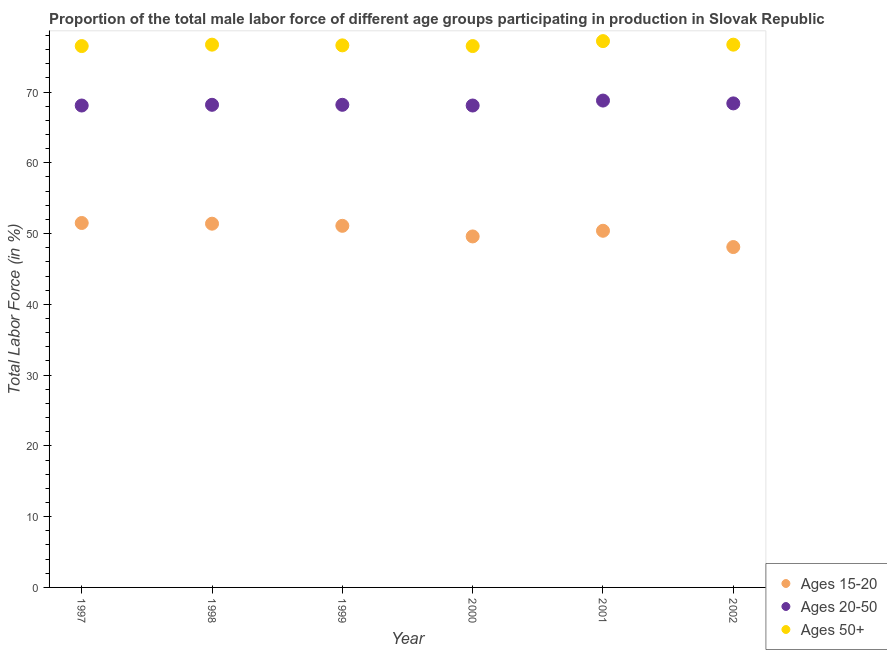How many different coloured dotlines are there?
Offer a very short reply. 3. Is the number of dotlines equal to the number of legend labels?
Keep it short and to the point. Yes. What is the percentage of male labor force within the age group 15-20 in 2002?
Your answer should be very brief. 48.1. Across all years, what is the maximum percentage of male labor force within the age group 15-20?
Your response must be concise. 51.5. Across all years, what is the minimum percentage of male labor force within the age group 20-50?
Offer a very short reply. 68.1. In which year was the percentage of male labor force above age 50 minimum?
Ensure brevity in your answer.  1997. What is the total percentage of male labor force within the age group 15-20 in the graph?
Keep it short and to the point. 302.1. What is the difference between the percentage of male labor force above age 50 in 1999 and that in 2002?
Provide a short and direct response. -0.1. What is the difference between the percentage of male labor force above age 50 in 1997 and the percentage of male labor force within the age group 20-50 in 2001?
Your answer should be compact. 7.7. What is the average percentage of male labor force above age 50 per year?
Make the answer very short. 76.7. In the year 2001, what is the difference between the percentage of male labor force within the age group 20-50 and percentage of male labor force above age 50?
Give a very brief answer. -8.4. In how many years, is the percentage of male labor force within the age group 15-20 greater than 22 %?
Make the answer very short. 6. What is the ratio of the percentage of male labor force within the age group 15-20 in 1997 to that in 1999?
Your answer should be very brief. 1.01. Is the difference between the percentage of male labor force within the age group 20-50 in 1997 and 2000 greater than the difference between the percentage of male labor force within the age group 15-20 in 1997 and 2000?
Provide a succinct answer. No. What is the difference between the highest and the second highest percentage of male labor force within the age group 15-20?
Offer a very short reply. 0.1. What is the difference between the highest and the lowest percentage of male labor force above age 50?
Provide a short and direct response. 0.7. Is it the case that in every year, the sum of the percentage of male labor force within the age group 15-20 and percentage of male labor force within the age group 20-50 is greater than the percentage of male labor force above age 50?
Ensure brevity in your answer.  Yes. How many years are there in the graph?
Give a very brief answer. 6. Does the graph contain any zero values?
Your answer should be very brief. No. Does the graph contain grids?
Make the answer very short. No. Where does the legend appear in the graph?
Provide a short and direct response. Bottom right. How many legend labels are there?
Offer a terse response. 3. How are the legend labels stacked?
Offer a terse response. Vertical. What is the title of the graph?
Your answer should be compact. Proportion of the total male labor force of different age groups participating in production in Slovak Republic. What is the label or title of the X-axis?
Your answer should be very brief. Year. What is the Total Labor Force (in %) of Ages 15-20 in 1997?
Provide a short and direct response. 51.5. What is the Total Labor Force (in %) in Ages 20-50 in 1997?
Your response must be concise. 68.1. What is the Total Labor Force (in %) in Ages 50+ in 1997?
Ensure brevity in your answer.  76.5. What is the Total Labor Force (in %) of Ages 15-20 in 1998?
Provide a succinct answer. 51.4. What is the Total Labor Force (in %) of Ages 20-50 in 1998?
Your answer should be very brief. 68.2. What is the Total Labor Force (in %) of Ages 50+ in 1998?
Provide a succinct answer. 76.7. What is the Total Labor Force (in %) in Ages 15-20 in 1999?
Provide a short and direct response. 51.1. What is the Total Labor Force (in %) of Ages 20-50 in 1999?
Your response must be concise. 68.2. What is the Total Labor Force (in %) of Ages 50+ in 1999?
Your response must be concise. 76.6. What is the Total Labor Force (in %) of Ages 15-20 in 2000?
Make the answer very short. 49.6. What is the Total Labor Force (in %) of Ages 20-50 in 2000?
Provide a short and direct response. 68.1. What is the Total Labor Force (in %) of Ages 50+ in 2000?
Ensure brevity in your answer.  76.5. What is the Total Labor Force (in %) of Ages 15-20 in 2001?
Give a very brief answer. 50.4. What is the Total Labor Force (in %) of Ages 20-50 in 2001?
Provide a succinct answer. 68.8. What is the Total Labor Force (in %) in Ages 50+ in 2001?
Give a very brief answer. 77.2. What is the Total Labor Force (in %) in Ages 15-20 in 2002?
Your response must be concise. 48.1. What is the Total Labor Force (in %) in Ages 20-50 in 2002?
Keep it short and to the point. 68.4. What is the Total Labor Force (in %) of Ages 50+ in 2002?
Keep it short and to the point. 76.7. Across all years, what is the maximum Total Labor Force (in %) in Ages 15-20?
Provide a short and direct response. 51.5. Across all years, what is the maximum Total Labor Force (in %) in Ages 20-50?
Your answer should be compact. 68.8. Across all years, what is the maximum Total Labor Force (in %) of Ages 50+?
Provide a short and direct response. 77.2. Across all years, what is the minimum Total Labor Force (in %) of Ages 15-20?
Give a very brief answer. 48.1. Across all years, what is the minimum Total Labor Force (in %) of Ages 20-50?
Give a very brief answer. 68.1. Across all years, what is the minimum Total Labor Force (in %) in Ages 50+?
Give a very brief answer. 76.5. What is the total Total Labor Force (in %) of Ages 15-20 in the graph?
Make the answer very short. 302.1. What is the total Total Labor Force (in %) of Ages 20-50 in the graph?
Offer a very short reply. 409.8. What is the total Total Labor Force (in %) in Ages 50+ in the graph?
Offer a very short reply. 460.2. What is the difference between the Total Labor Force (in %) in Ages 20-50 in 1997 and that in 2000?
Offer a terse response. 0. What is the difference between the Total Labor Force (in %) of Ages 50+ in 1997 and that in 2000?
Your answer should be very brief. 0. What is the difference between the Total Labor Force (in %) of Ages 20-50 in 1997 and that in 2001?
Your response must be concise. -0.7. What is the difference between the Total Labor Force (in %) of Ages 50+ in 1997 and that in 2002?
Your answer should be compact. -0.2. What is the difference between the Total Labor Force (in %) of Ages 20-50 in 1998 and that in 1999?
Provide a short and direct response. 0. What is the difference between the Total Labor Force (in %) in Ages 50+ in 1998 and that in 2001?
Offer a terse response. -0.5. What is the difference between the Total Labor Force (in %) of Ages 20-50 in 1999 and that in 2001?
Give a very brief answer. -0.6. What is the difference between the Total Labor Force (in %) in Ages 15-20 in 1999 and that in 2002?
Your answer should be very brief. 3. What is the difference between the Total Labor Force (in %) of Ages 50+ in 1999 and that in 2002?
Your answer should be compact. -0.1. What is the difference between the Total Labor Force (in %) of Ages 15-20 in 2000 and that in 2001?
Your response must be concise. -0.8. What is the difference between the Total Labor Force (in %) in Ages 20-50 in 2000 and that in 2001?
Your response must be concise. -0.7. What is the difference between the Total Labor Force (in %) in Ages 50+ in 2000 and that in 2001?
Make the answer very short. -0.7. What is the difference between the Total Labor Force (in %) of Ages 20-50 in 2000 and that in 2002?
Offer a very short reply. -0.3. What is the difference between the Total Labor Force (in %) in Ages 15-20 in 2001 and that in 2002?
Offer a very short reply. 2.3. What is the difference between the Total Labor Force (in %) of Ages 20-50 in 2001 and that in 2002?
Offer a terse response. 0.4. What is the difference between the Total Labor Force (in %) of Ages 15-20 in 1997 and the Total Labor Force (in %) of Ages 20-50 in 1998?
Provide a short and direct response. -16.7. What is the difference between the Total Labor Force (in %) in Ages 15-20 in 1997 and the Total Labor Force (in %) in Ages 50+ in 1998?
Keep it short and to the point. -25.2. What is the difference between the Total Labor Force (in %) in Ages 20-50 in 1997 and the Total Labor Force (in %) in Ages 50+ in 1998?
Keep it short and to the point. -8.6. What is the difference between the Total Labor Force (in %) in Ages 15-20 in 1997 and the Total Labor Force (in %) in Ages 20-50 in 1999?
Your answer should be compact. -16.7. What is the difference between the Total Labor Force (in %) in Ages 15-20 in 1997 and the Total Labor Force (in %) in Ages 50+ in 1999?
Your answer should be very brief. -25.1. What is the difference between the Total Labor Force (in %) in Ages 15-20 in 1997 and the Total Labor Force (in %) in Ages 20-50 in 2000?
Your response must be concise. -16.6. What is the difference between the Total Labor Force (in %) in Ages 15-20 in 1997 and the Total Labor Force (in %) in Ages 20-50 in 2001?
Your answer should be very brief. -17.3. What is the difference between the Total Labor Force (in %) of Ages 15-20 in 1997 and the Total Labor Force (in %) of Ages 50+ in 2001?
Keep it short and to the point. -25.7. What is the difference between the Total Labor Force (in %) of Ages 20-50 in 1997 and the Total Labor Force (in %) of Ages 50+ in 2001?
Ensure brevity in your answer.  -9.1. What is the difference between the Total Labor Force (in %) in Ages 15-20 in 1997 and the Total Labor Force (in %) in Ages 20-50 in 2002?
Make the answer very short. -16.9. What is the difference between the Total Labor Force (in %) of Ages 15-20 in 1997 and the Total Labor Force (in %) of Ages 50+ in 2002?
Offer a terse response. -25.2. What is the difference between the Total Labor Force (in %) in Ages 15-20 in 1998 and the Total Labor Force (in %) in Ages 20-50 in 1999?
Your answer should be very brief. -16.8. What is the difference between the Total Labor Force (in %) of Ages 15-20 in 1998 and the Total Labor Force (in %) of Ages 50+ in 1999?
Provide a succinct answer. -25.2. What is the difference between the Total Labor Force (in %) in Ages 20-50 in 1998 and the Total Labor Force (in %) in Ages 50+ in 1999?
Provide a short and direct response. -8.4. What is the difference between the Total Labor Force (in %) in Ages 15-20 in 1998 and the Total Labor Force (in %) in Ages 20-50 in 2000?
Make the answer very short. -16.7. What is the difference between the Total Labor Force (in %) in Ages 15-20 in 1998 and the Total Labor Force (in %) in Ages 50+ in 2000?
Your response must be concise. -25.1. What is the difference between the Total Labor Force (in %) in Ages 15-20 in 1998 and the Total Labor Force (in %) in Ages 20-50 in 2001?
Give a very brief answer. -17.4. What is the difference between the Total Labor Force (in %) in Ages 15-20 in 1998 and the Total Labor Force (in %) in Ages 50+ in 2001?
Offer a very short reply. -25.8. What is the difference between the Total Labor Force (in %) of Ages 20-50 in 1998 and the Total Labor Force (in %) of Ages 50+ in 2001?
Provide a short and direct response. -9. What is the difference between the Total Labor Force (in %) in Ages 15-20 in 1998 and the Total Labor Force (in %) in Ages 20-50 in 2002?
Your answer should be compact. -17. What is the difference between the Total Labor Force (in %) of Ages 15-20 in 1998 and the Total Labor Force (in %) of Ages 50+ in 2002?
Offer a very short reply. -25.3. What is the difference between the Total Labor Force (in %) of Ages 20-50 in 1998 and the Total Labor Force (in %) of Ages 50+ in 2002?
Offer a very short reply. -8.5. What is the difference between the Total Labor Force (in %) of Ages 15-20 in 1999 and the Total Labor Force (in %) of Ages 20-50 in 2000?
Offer a terse response. -17. What is the difference between the Total Labor Force (in %) of Ages 15-20 in 1999 and the Total Labor Force (in %) of Ages 50+ in 2000?
Provide a succinct answer. -25.4. What is the difference between the Total Labor Force (in %) of Ages 20-50 in 1999 and the Total Labor Force (in %) of Ages 50+ in 2000?
Offer a terse response. -8.3. What is the difference between the Total Labor Force (in %) in Ages 15-20 in 1999 and the Total Labor Force (in %) in Ages 20-50 in 2001?
Offer a very short reply. -17.7. What is the difference between the Total Labor Force (in %) of Ages 15-20 in 1999 and the Total Labor Force (in %) of Ages 50+ in 2001?
Your answer should be very brief. -26.1. What is the difference between the Total Labor Force (in %) of Ages 20-50 in 1999 and the Total Labor Force (in %) of Ages 50+ in 2001?
Offer a very short reply. -9. What is the difference between the Total Labor Force (in %) of Ages 15-20 in 1999 and the Total Labor Force (in %) of Ages 20-50 in 2002?
Your response must be concise. -17.3. What is the difference between the Total Labor Force (in %) in Ages 15-20 in 1999 and the Total Labor Force (in %) in Ages 50+ in 2002?
Your answer should be compact. -25.6. What is the difference between the Total Labor Force (in %) of Ages 15-20 in 2000 and the Total Labor Force (in %) of Ages 20-50 in 2001?
Your answer should be very brief. -19.2. What is the difference between the Total Labor Force (in %) in Ages 15-20 in 2000 and the Total Labor Force (in %) in Ages 50+ in 2001?
Ensure brevity in your answer.  -27.6. What is the difference between the Total Labor Force (in %) of Ages 20-50 in 2000 and the Total Labor Force (in %) of Ages 50+ in 2001?
Offer a terse response. -9.1. What is the difference between the Total Labor Force (in %) of Ages 15-20 in 2000 and the Total Labor Force (in %) of Ages 20-50 in 2002?
Offer a very short reply. -18.8. What is the difference between the Total Labor Force (in %) in Ages 15-20 in 2000 and the Total Labor Force (in %) in Ages 50+ in 2002?
Provide a short and direct response. -27.1. What is the difference between the Total Labor Force (in %) of Ages 20-50 in 2000 and the Total Labor Force (in %) of Ages 50+ in 2002?
Give a very brief answer. -8.6. What is the difference between the Total Labor Force (in %) in Ages 15-20 in 2001 and the Total Labor Force (in %) in Ages 20-50 in 2002?
Provide a succinct answer. -18. What is the difference between the Total Labor Force (in %) of Ages 15-20 in 2001 and the Total Labor Force (in %) of Ages 50+ in 2002?
Make the answer very short. -26.3. What is the average Total Labor Force (in %) of Ages 15-20 per year?
Keep it short and to the point. 50.35. What is the average Total Labor Force (in %) of Ages 20-50 per year?
Ensure brevity in your answer.  68.3. What is the average Total Labor Force (in %) of Ages 50+ per year?
Ensure brevity in your answer.  76.7. In the year 1997, what is the difference between the Total Labor Force (in %) of Ages 15-20 and Total Labor Force (in %) of Ages 20-50?
Your answer should be compact. -16.6. In the year 1997, what is the difference between the Total Labor Force (in %) in Ages 20-50 and Total Labor Force (in %) in Ages 50+?
Your answer should be very brief. -8.4. In the year 1998, what is the difference between the Total Labor Force (in %) in Ages 15-20 and Total Labor Force (in %) in Ages 20-50?
Provide a succinct answer. -16.8. In the year 1998, what is the difference between the Total Labor Force (in %) of Ages 15-20 and Total Labor Force (in %) of Ages 50+?
Ensure brevity in your answer.  -25.3. In the year 1998, what is the difference between the Total Labor Force (in %) in Ages 20-50 and Total Labor Force (in %) in Ages 50+?
Your answer should be very brief. -8.5. In the year 1999, what is the difference between the Total Labor Force (in %) in Ages 15-20 and Total Labor Force (in %) in Ages 20-50?
Your answer should be compact. -17.1. In the year 1999, what is the difference between the Total Labor Force (in %) in Ages 15-20 and Total Labor Force (in %) in Ages 50+?
Your answer should be very brief. -25.5. In the year 1999, what is the difference between the Total Labor Force (in %) in Ages 20-50 and Total Labor Force (in %) in Ages 50+?
Make the answer very short. -8.4. In the year 2000, what is the difference between the Total Labor Force (in %) in Ages 15-20 and Total Labor Force (in %) in Ages 20-50?
Your answer should be very brief. -18.5. In the year 2000, what is the difference between the Total Labor Force (in %) in Ages 15-20 and Total Labor Force (in %) in Ages 50+?
Make the answer very short. -26.9. In the year 2001, what is the difference between the Total Labor Force (in %) in Ages 15-20 and Total Labor Force (in %) in Ages 20-50?
Give a very brief answer. -18.4. In the year 2001, what is the difference between the Total Labor Force (in %) of Ages 15-20 and Total Labor Force (in %) of Ages 50+?
Provide a short and direct response. -26.8. In the year 2001, what is the difference between the Total Labor Force (in %) of Ages 20-50 and Total Labor Force (in %) of Ages 50+?
Keep it short and to the point. -8.4. In the year 2002, what is the difference between the Total Labor Force (in %) of Ages 15-20 and Total Labor Force (in %) of Ages 20-50?
Make the answer very short. -20.3. In the year 2002, what is the difference between the Total Labor Force (in %) of Ages 15-20 and Total Labor Force (in %) of Ages 50+?
Keep it short and to the point. -28.6. What is the ratio of the Total Labor Force (in %) of Ages 15-20 in 1997 to that in 1998?
Your response must be concise. 1. What is the ratio of the Total Labor Force (in %) of Ages 20-50 in 1997 to that in 1998?
Provide a succinct answer. 1. What is the ratio of the Total Labor Force (in %) in Ages 15-20 in 1997 to that in 1999?
Provide a succinct answer. 1.01. What is the ratio of the Total Labor Force (in %) of Ages 50+ in 1997 to that in 1999?
Provide a succinct answer. 1. What is the ratio of the Total Labor Force (in %) of Ages 15-20 in 1997 to that in 2000?
Offer a terse response. 1.04. What is the ratio of the Total Labor Force (in %) of Ages 20-50 in 1997 to that in 2000?
Offer a very short reply. 1. What is the ratio of the Total Labor Force (in %) in Ages 50+ in 1997 to that in 2000?
Make the answer very short. 1. What is the ratio of the Total Labor Force (in %) of Ages 15-20 in 1997 to that in 2001?
Give a very brief answer. 1.02. What is the ratio of the Total Labor Force (in %) in Ages 50+ in 1997 to that in 2001?
Your answer should be very brief. 0.99. What is the ratio of the Total Labor Force (in %) in Ages 15-20 in 1997 to that in 2002?
Your answer should be compact. 1.07. What is the ratio of the Total Labor Force (in %) of Ages 50+ in 1997 to that in 2002?
Offer a terse response. 1. What is the ratio of the Total Labor Force (in %) in Ages 15-20 in 1998 to that in 1999?
Your response must be concise. 1.01. What is the ratio of the Total Labor Force (in %) in Ages 15-20 in 1998 to that in 2000?
Ensure brevity in your answer.  1.04. What is the ratio of the Total Labor Force (in %) of Ages 50+ in 1998 to that in 2000?
Ensure brevity in your answer.  1. What is the ratio of the Total Labor Force (in %) in Ages 15-20 in 1998 to that in 2001?
Your answer should be very brief. 1.02. What is the ratio of the Total Labor Force (in %) of Ages 50+ in 1998 to that in 2001?
Provide a short and direct response. 0.99. What is the ratio of the Total Labor Force (in %) in Ages 15-20 in 1998 to that in 2002?
Your answer should be compact. 1.07. What is the ratio of the Total Labor Force (in %) in Ages 50+ in 1998 to that in 2002?
Keep it short and to the point. 1. What is the ratio of the Total Labor Force (in %) of Ages 15-20 in 1999 to that in 2000?
Offer a terse response. 1.03. What is the ratio of the Total Labor Force (in %) in Ages 20-50 in 1999 to that in 2000?
Provide a succinct answer. 1. What is the ratio of the Total Labor Force (in %) of Ages 50+ in 1999 to that in 2000?
Give a very brief answer. 1. What is the ratio of the Total Labor Force (in %) of Ages 15-20 in 1999 to that in 2001?
Give a very brief answer. 1.01. What is the ratio of the Total Labor Force (in %) in Ages 20-50 in 1999 to that in 2001?
Provide a succinct answer. 0.99. What is the ratio of the Total Labor Force (in %) in Ages 50+ in 1999 to that in 2001?
Your response must be concise. 0.99. What is the ratio of the Total Labor Force (in %) in Ages 15-20 in 1999 to that in 2002?
Make the answer very short. 1.06. What is the ratio of the Total Labor Force (in %) in Ages 20-50 in 1999 to that in 2002?
Make the answer very short. 1. What is the ratio of the Total Labor Force (in %) in Ages 50+ in 1999 to that in 2002?
Offer a terse response. 1. What is the ratio of the Total Labor Force (in %) of Ages 15-20 in 2000 to that in 2001?
Ensure brevity in your answer.  0.98. What is the ratio of the Total Labor Force (in %) of Ages 20-50 in 2000 to that in 2001?
Make the answer very short. 0.99. What is the ratio of the Total Labor Force (in %) of Ages 50+ in 2000 to that in 2001?
Your response must be concise. 0.99. What is the ratio of the Total Labor Force (in %) of Ages 15-20 in 2000 to that in 2002?
Your answer should be very brief. 1.03. What is the ratio of the Total Labor Force (in %) in Ages 20-50 in 2000 to that in 2002?
Make the answer very short. 1. What is the ratio of the Total Labor Force (in %) in Ages 50+ in 2000 to that in 2002?
Your response must be concise. 1. What is the ratio of the Total Labor Force (in %) of Ages 15-20 in 2001 to that in 2002?
Provide a short and direct response. 1.05. What is the ratio of the Total Labor Force (in %) in Ages 20-50 in 2001 to that in 2002?
Make the answer very short. 1.01. What is the ratio of the Total Labor Force (in %) of Ages 50+ in 2001 to that in 2002?
Offer a very short reply. 1.01. What is the difference between the highest and the second highest Total Labor Force (in %) in Ages 15-20?
Offer a very short reply. 0.1. What is the difference between the highest and the second highest Total Labor Force (in %) of Ages 20-50?
Provide a succinct answer. 0.4. What is the difference between the highest and the second highest Total Labor Force (in %) of Ages 50+?
Make the answer very short. 0.5. 